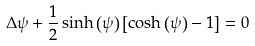Convert formula to latex. <formula><loc_0><loc_0><loc_500><loc_500>\Delta \psi + \frac { 1 } { 2 } \sinh \left ( \psi \right ) \left [ \cosh \left ( \psi \right ) - 1 \right ] = 0</formula> 